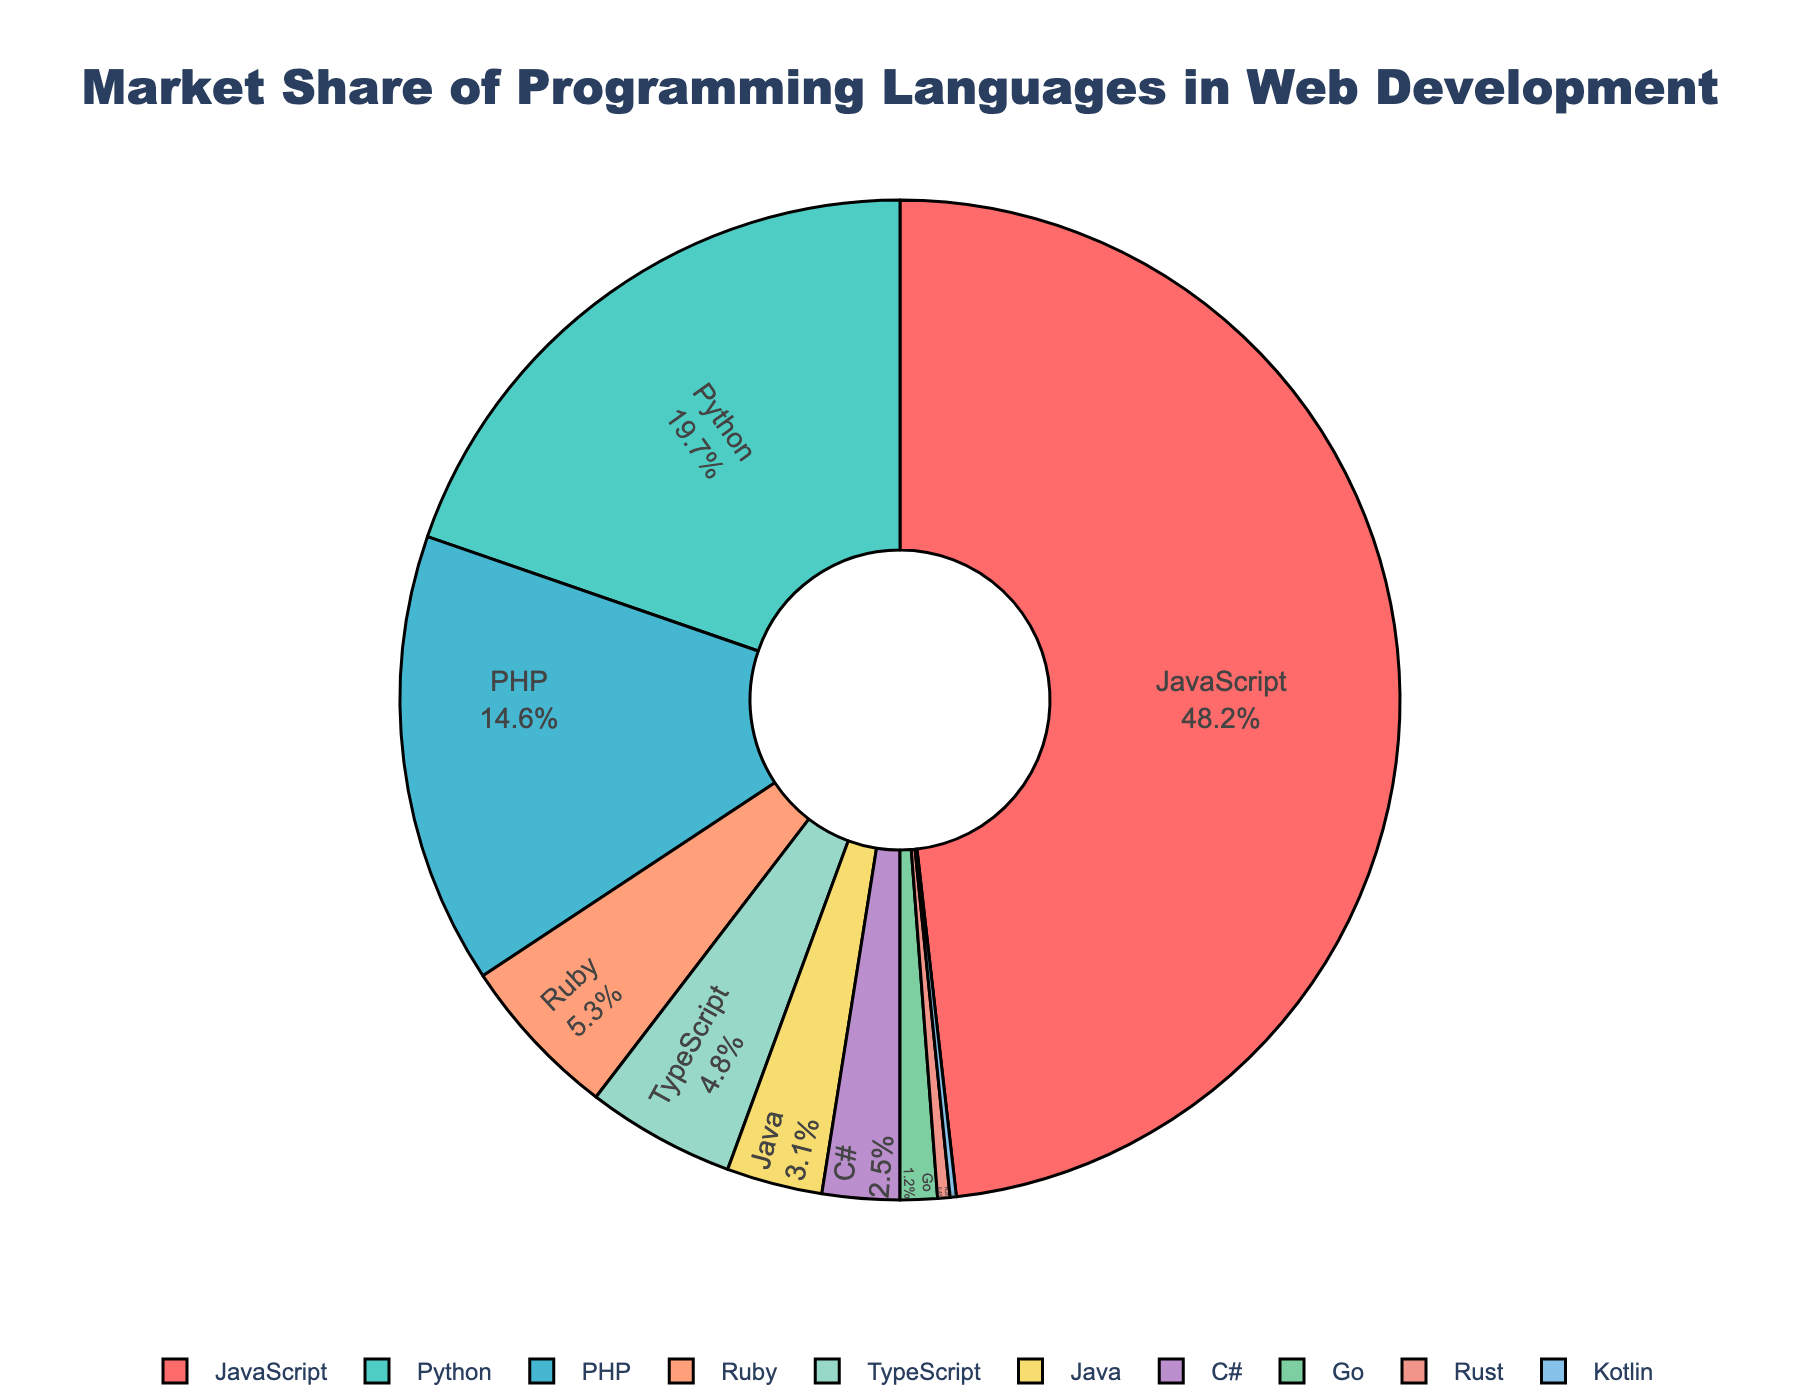What is the market share of JavaScript in web development? From the figure, identify the slice labeled "JavaScript" and check its associated percentage, which is prominently displayed.
Answer: 48.2% Which programming language has the second-highest market share? Identify the language with the second-largest slice after JavaScript by comparing the sizes of the pie chart portions. This is the segment labeled "Python".
Answer: Python Calculate the combined market share of JavaScript and Python. Find the percentages for JavaScript and Python, which are 48.2% and 19.7% respectively, and add them together: 48.2% + 19.7% = 67.9%.
Answer: 67.9% What is the difference in market share between PHP and Ruby? Locate the percentages for PHP (14.6%) and Ruby (5.3%) on the chart, then subtract Ruby's percentage from PHP's: 14.6% - 5.3% = 9.3%.
Answer: 9.3% Compare the market share of TypeScript with that of Java. From the figure, note the market shares of TypeScript (4.8%) and Java (3.1%). TypeScript has a higher market share.
Answer: TypeScript has a higher market share What is the combined market share of programming languages that each have less than 5% market share? Identify the languages with less than 5%: Ruby (5.3%), TypeScript (4.8%), Java (3.1%), C# (2.5%), Go (1.2%), Rust (0.4%), Kotlin (0.2%). Add percentages of TypeScript, Java, C#, Go, Rust, and Kotlin: 4.8% + 3.1% + 2.5% + 1.2% + 0.4% + 0.2% = 12.2%.
Answer: 12.2% Which language slice is colored in red? Identify the pie chart slice color corresponding to red and check the label. JavaScript is the language that is colored in red.
Answer: JavaScript From the visual distribution, are there more languages with market shares above or below 10%? Count the number of segments above 10% (JavaScript, Python, PHP) and below 10% (the rest). There are 3 languages above and 7 below.
Answer: More languages have market shares below 10% 